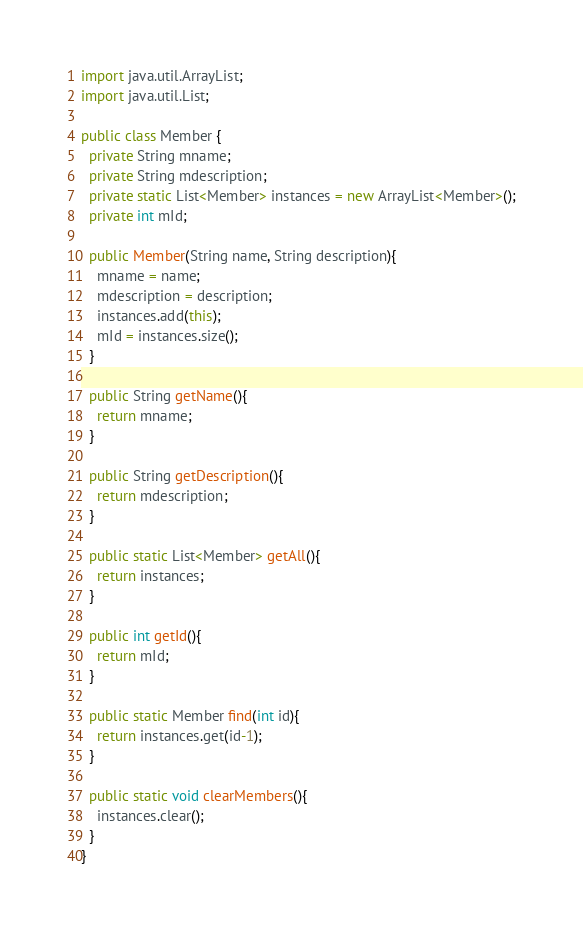Convert code to text. <code><loc_0><loc_0><loc_500><loc_500><_Java_>import java.util.ArrayList;
import java.util.List;

public class Member {
  private String mname;
  private String mdescription;
  private static List<Member> instances = new ArrayList<Member>();
  private int mId;

  public Member(String name, String description){
    mname = name;
    mdescription = description;
    instances.add(this);
    mId = instances.size();
  }

  public String getName(){
    return mname;
  }

  public String getDescription(){
    return mdescription;
  }

  public static List<Member> getAll(){
    return instances;
  }

  public int getId(){
    return mId;
  }

  public static Member find(int id){
    return instances.get(id-1);
  }

  public static void clearMembers(){
    instances.clear();
  }
}
</code> 